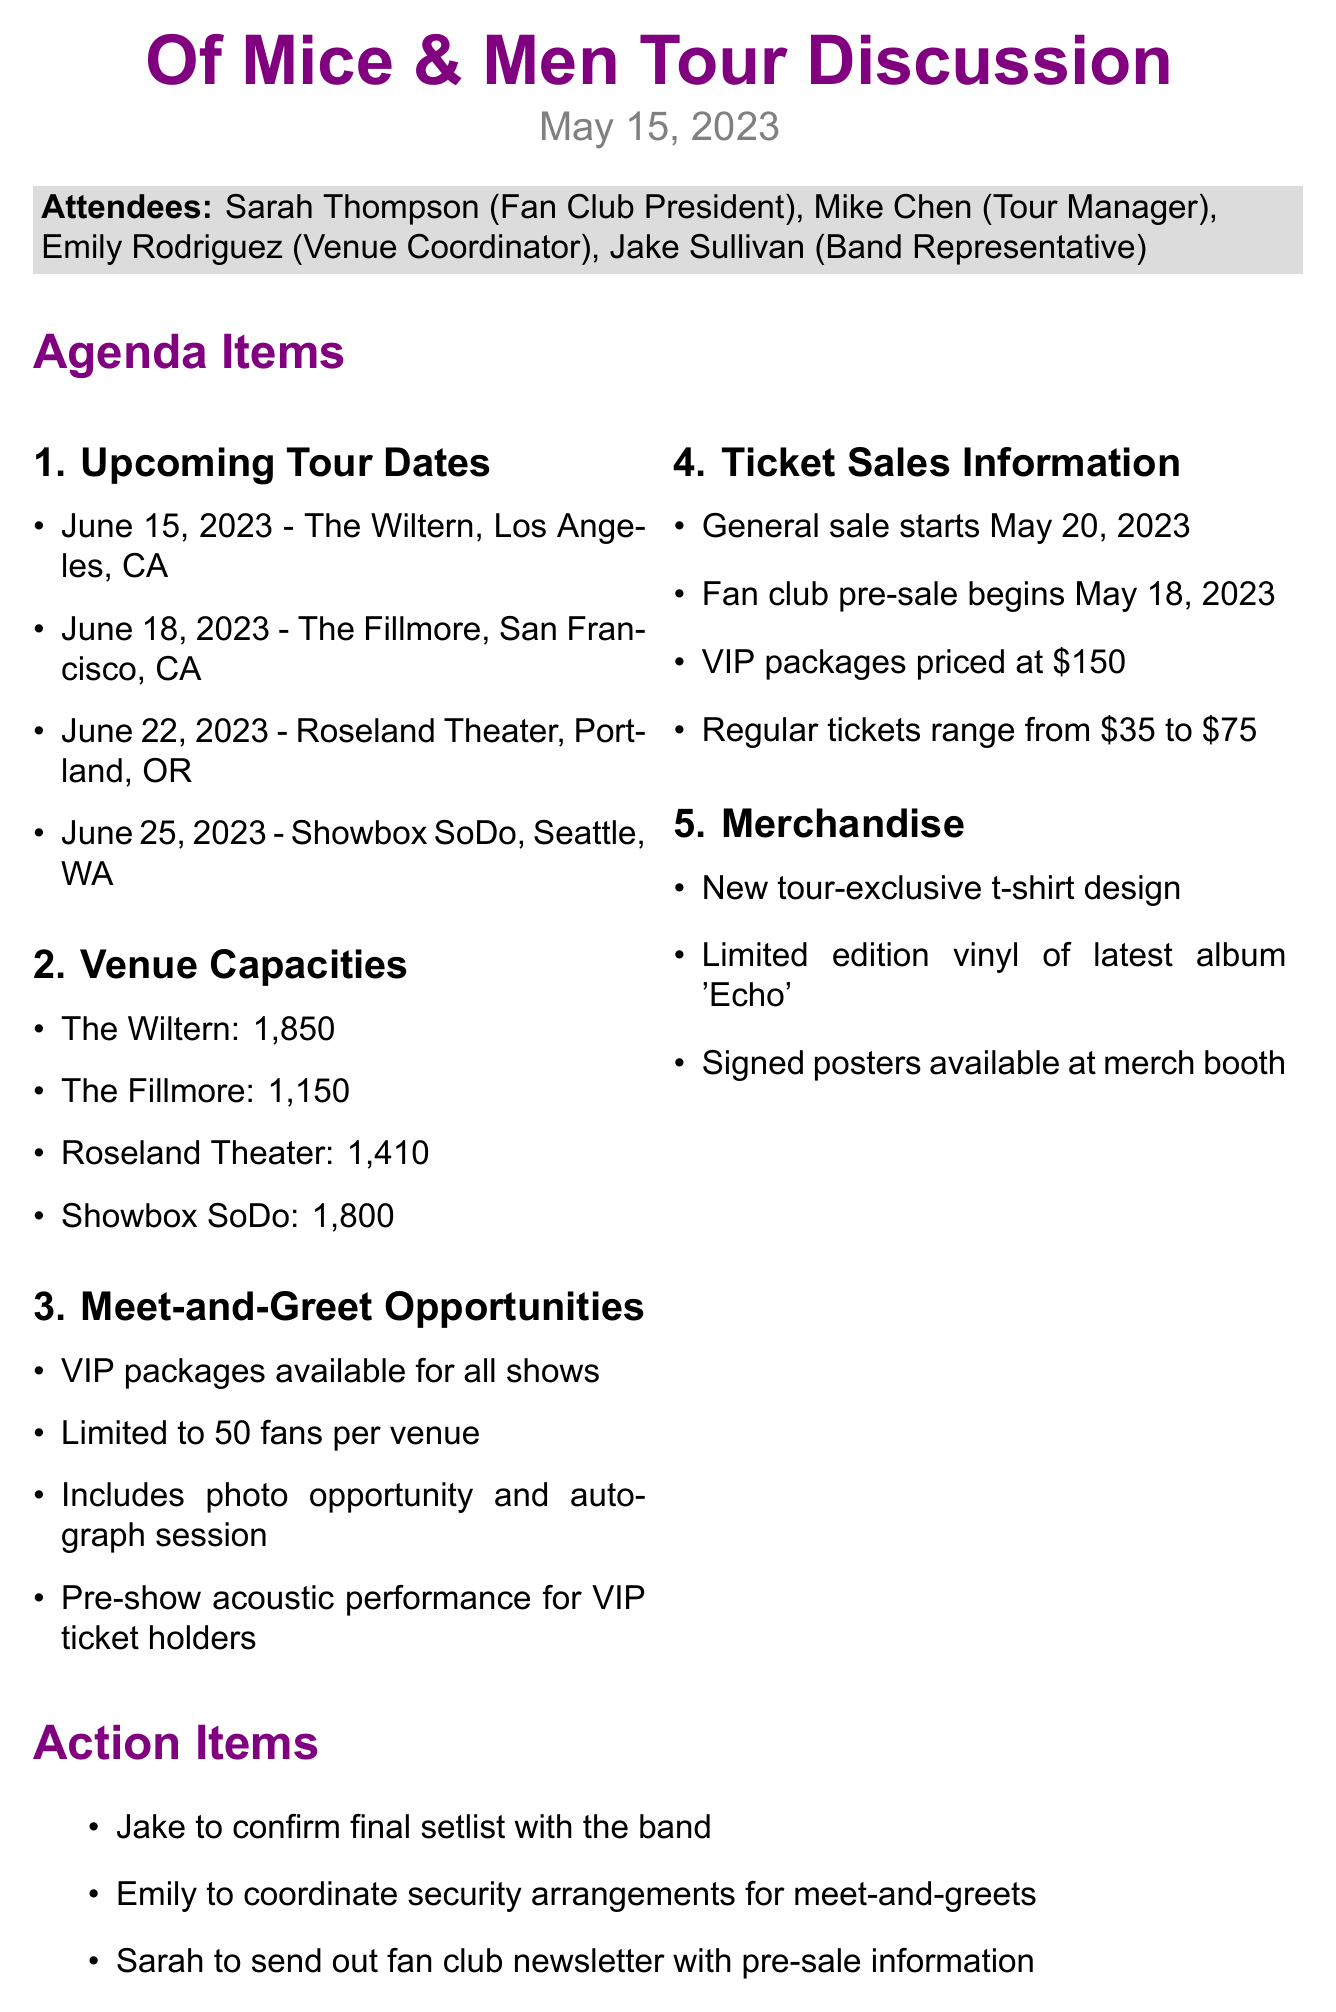What are the upcoming tour dates? The upcoming tour dates are listed under the agenda item "Upcoming Tour Dates."
Answer: June 15, 2023 - The Wiltern, Los Angeles, CA; June 18, 2023 - The Fillmore, San Francisco, CA; June 22, 2023 - Roseland Theater, Portland, OR; June 25, 2023 - Showbox SoDo, Seattle, WA What is the capacity of The Fillmore? The capacity of The Fillmore is listed under the agenda item "Venue Capacities."
Answer: 1,150 How many fans are allowed for meet-and-greet per venue? The number of fans allowed for meet-and-greet is specified in the "Meet-and-Greet Opportunities" section.
Answer: 50 When does the general ticket sale start? The start date for the general ticket sale is mentioned in the "Ticket Sales Information" section.
Answer: May 20, 2023 What is the price range for regular tickets? The price range for regular tickets is detailed in the "Ticket Sales Information" section.
Answer: $35 to $75 Who is responsible for coordinating security arrangements for meet-and-greets? The action item lists who is responsible for coordinating security for meet-and-greets.
Answer: Emily What type of merchandise will be available? The types of merchandise available are specified under the "Merchandise" section.
Answer: New tour-exclusive t-shirt design, limited edition vinyl, signed posters What is included in the VIP packages? The contents of the VIP packages are specified in the "Meet-and-Greet Opportunities" section.
Answer: Photo opportunity, autograph session, pre-show acoustic performance 